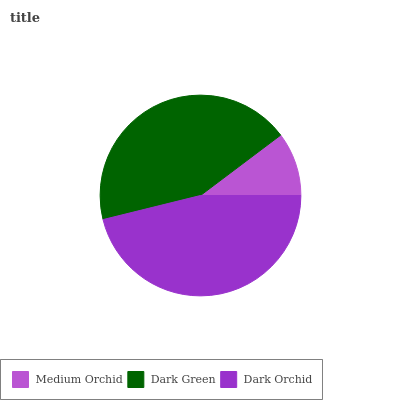Is Medium Orchid the minimum?
Answer yes or no. Yes. Is Dark Orchid the maximum?
Answer yes or no. Yes. Is Dark Green the minimum?
Answer yes or no. No. Is Dark Green the maximum?
Answer yes or no. No. Is Dark Green greater than Medium Orchid?
Answer yes or no. Yes. Is Medium Orchid less than Dark Green?
Answer yes or no. Yes. Is Medium Orchid greater than Dark Green?
Answer yes or no. No. Is Dark Green less than Medium Orchid?
Answer yes or no. No. Is Dark Green the high median?
Answer yes or no. Yes. Is Dark Green the low median?
Answer yes or no. Yes. Is Medium Orchid the high median?
Answer yes or no. No. Is Medium Orchid the low median?
Answer yes or no. No. 